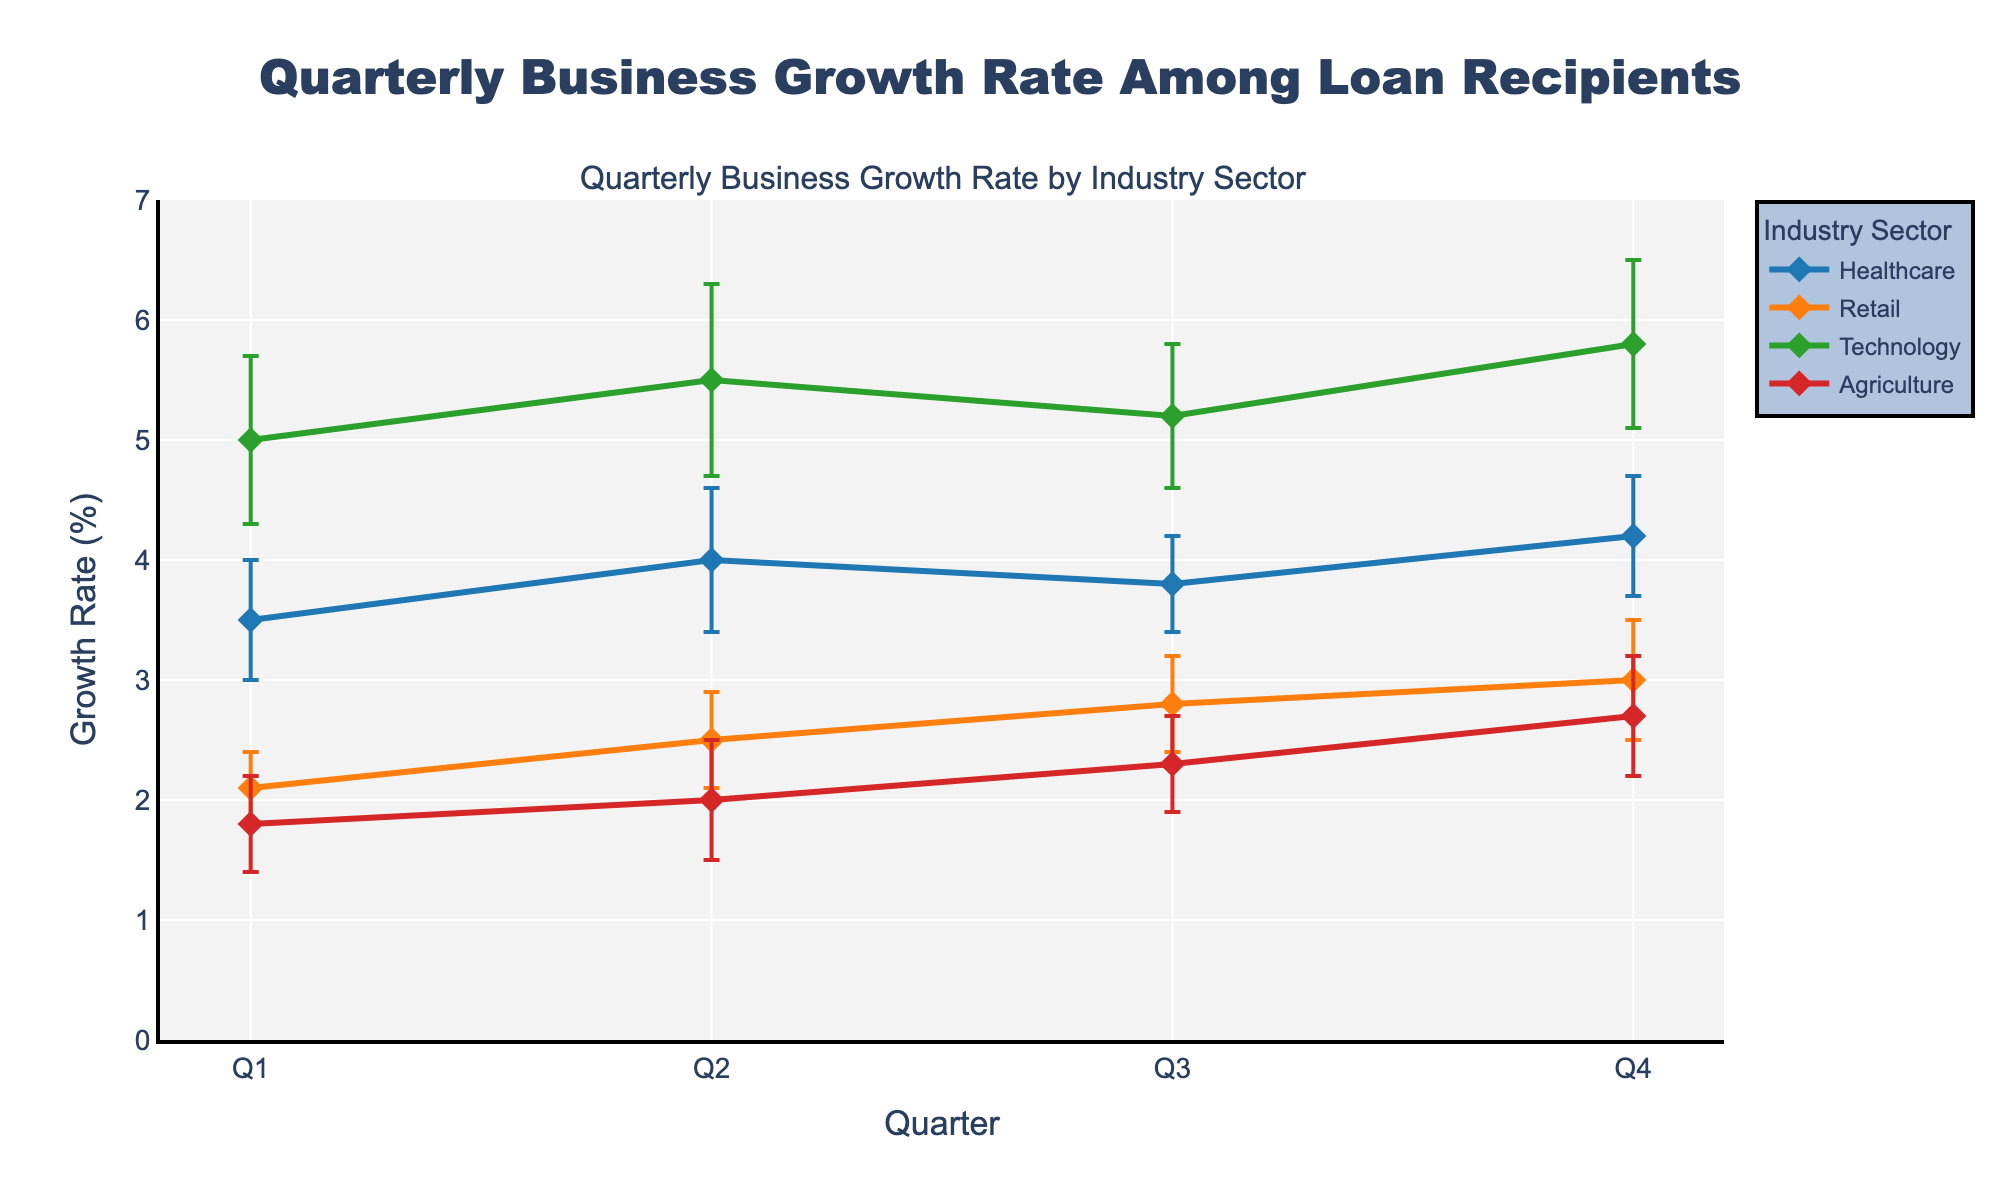What is the title of the figure? The title of the figure is displayed at the top of the chart and reads "Quarterly Business Growth Rate Among Loan Recipients."
Answer: Quarterly Business Growth Rate Among Loan Recipients What are the four industry sectors shown in the plot? The industry sectors are labeled in both the legend and the colored lines in the plot. The sectors are Healthcare, Retail, Technology, and Agriculture.
Answer: Healthcare, Retail, Technology, Agriculture Which industry sector has the highest mean growth rate in Q4? By examining the highest data points on the y-axis for Q4, Technology reaches the highest at 5.8%.
Answer: Technology What is the range of growth rates for the Retail sector in Q2? The Retail sector's mean growth rate in Q2 is 2.5%, with a confidence interval of 0.4%. The range is from 2.1% to 2.9% which are the lower and upper bounds, respectively.
Answer: 2.1%-2.9% What is the average growth rate of the Agriculture sector across all quarters? Sum the mean growth rates of Agriculture for all quarters (1.8 + 2.0 + 2.3 + 2.7) and then divide by 4. The average is (1.8 + 2.0 + 2.3 + 2.7) / 4 = 2.2%.
Answer: 2.2% How does the growth rate for Healthcare compare between Q1 and Q4? Healthcare has a mean growth rate in Q1 of 3.5% and in Q4 of 4.2%. The growth rate increased by 4.2% - 3.5% = 0.7%.
Answer: Increased by 0.7% Which industry sector has the highest variability (or the largest confidence interval) for any quarter? By looking at the confidence intervals, Technology has the largest at 0.8% in Q2.
Answer: Technology in Q2 In which quarter did the Healthcare sector show the highest mean growth rate? By inspecting the plot, the highest mean growth rate for Healthcare occurs in Q4 at 4.2%.
Answer: Q4 How many data points are there for each industry sector in the plot? Each industry sector has data points for four quarters: Q1, Q2, Q3, and Q4. Therefore, each sector has 4 data points.
Answer: 4 data points Did any industry sector remain constant in growth rate between any two consecutive quarters? By tracing the lines for all sectors, none of the sectors show a constant mean growth rate between any two consecutive quarters.
Answer: No 